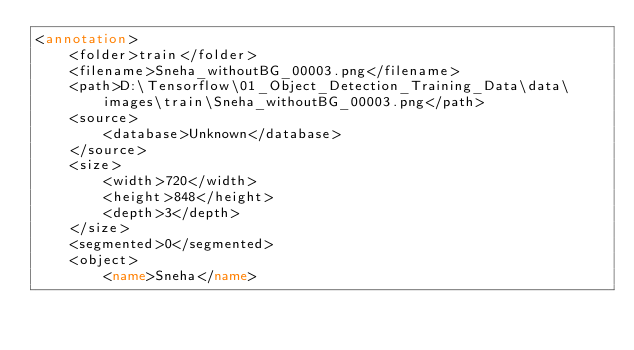Convert code to text. <code><loc_0><loc_0><loc_500><loc_500><_XML_><annotation>
	<folder>train</folder>
	<filename>Sneha_withoutBG_00003.png</filename>
	<path>D:\Tensorflow\01_Object_Detection_Training_Data\data\images\train\Sneha_withoutBG_00003.png</path>
	<source>
		<database>Unknown</database>
	</source>
	<size>
		<width>720</width>
		<height>848</height>
		<depth>3</depth>
	</size>
	<segmented>0</segmented>
	<object>
		<name>Sneha</name></code> 